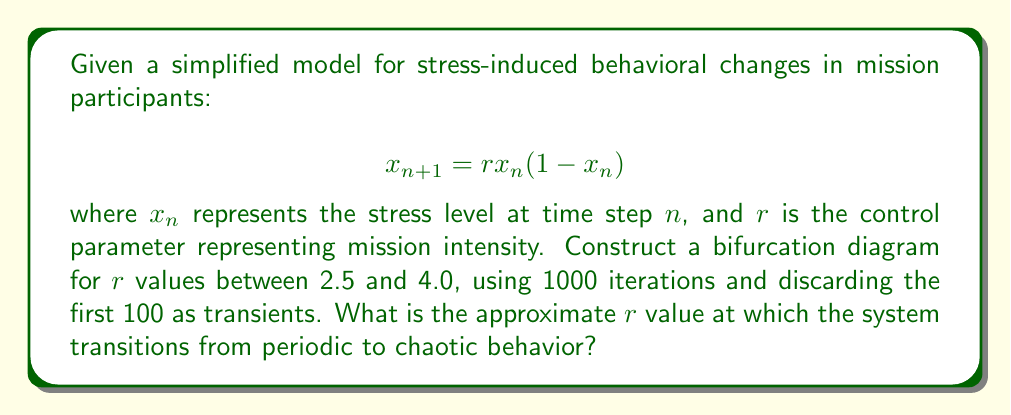Teach me how to tackle this problem. To construct the bifurcation diagram and identify the transition point from periodic to chaotic behavior, we follow these steps:

1) Initialize the system:
   - Set $x_0 = 0.5$ (arbitrary initial condition)
   - Define $r$ range: 2.5 to 4.0
   - Use 1000 iterations, discard first 100 as transients

2) For each $r$ value (increment by small steps, e.g., 0.001):
   a) Iterate the map 1000 times: $x_{n+1} = rx_n(1-x_n)$
   b) Plot the last 900 points $(r, x_n)$

3) Analyze the resulting bifurcation diagram:
   - Look for the point where period-doubling cascades transition to chaos
   - This occurs when the distinct branches become indistinguishable and form a continuous band

4) The transition point is approximately at $r \approx 3.57$, known as the onset of chaos or the accumulation point of the period-doubling cascade.

5) This value is significant because:
   - For $r < 3.57$, the system exhibits periodic behavior
   - For $r > 3.57$, the system shows chaotic behavior with some periodic windows

6) The exact value is the Feigenbaum point: $r_∞ ≈ 3.569946...$

[asy]
import graph;
size(300,200);
real f(real x, real r) {return r*x*(1-x);}
int n = 1000;
int m = 100;
for (real r = 2.5; r <= 4; r += 0.005) {
  real x = 0.5;
  for (int i = 0; i < n; ++i) {
    x = f(x,r);
    if (i >= m) dot((r,x),blue+0.2pt);
  }
}
xaxis("r",xmin=2.5,xmax=4,arrow=Arrow);
yaxis("x",ymin=0,ymax=1,arrow=Arrow);
label("Periodic",point(S),S);
label("Chaotic",point(E),E);
draw((3.57,0)--(3.57,1),red+dashed);
label("r ≈ 3.57",(3.57,1),N);
[/asy]
Answer: $r \approx 3.57$ 